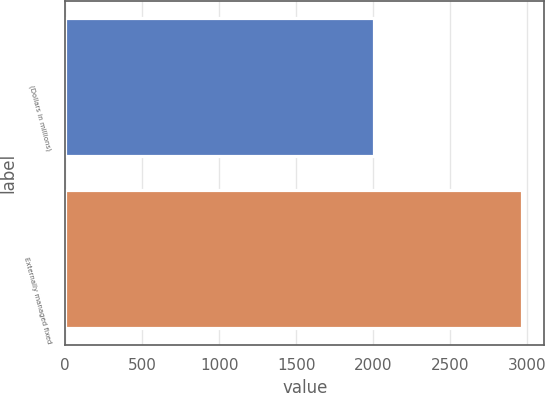<chart> <loc_0><loc_0><loc_500><loc_500><bar_chart><fcel>(Dollars in millions)<fcel>Externally managed fixed<nl><fcel>2007<fcel>2963<nl></chart> 